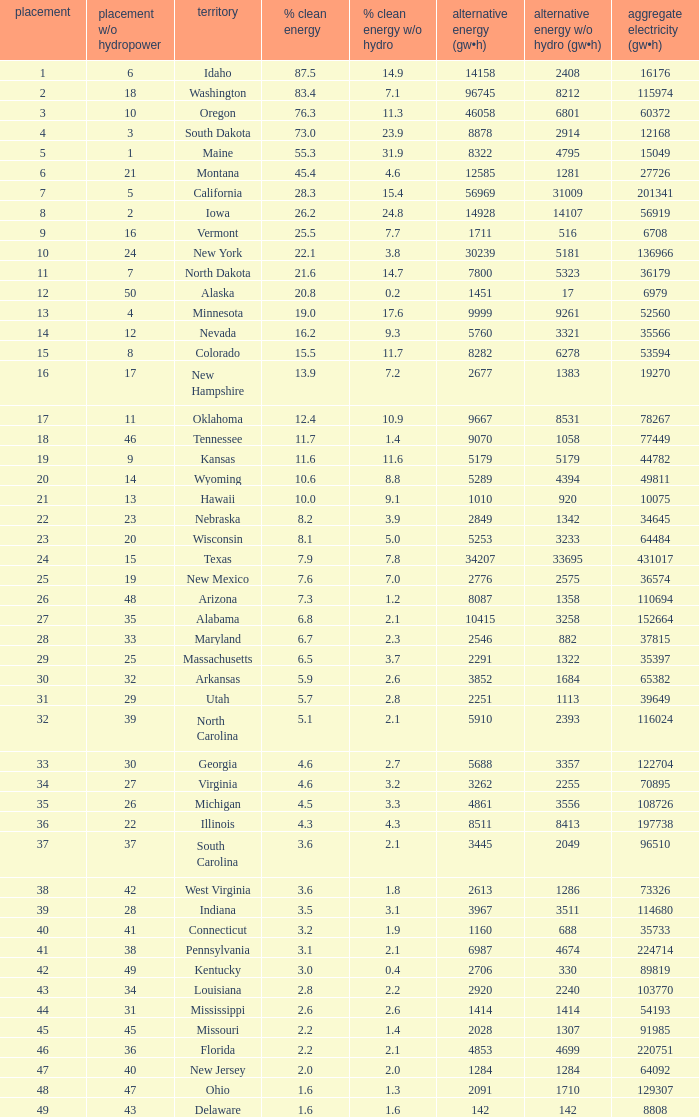Which state has 5179 (gw×h) of renewable energy without hydrogen power?wha Kansas. 